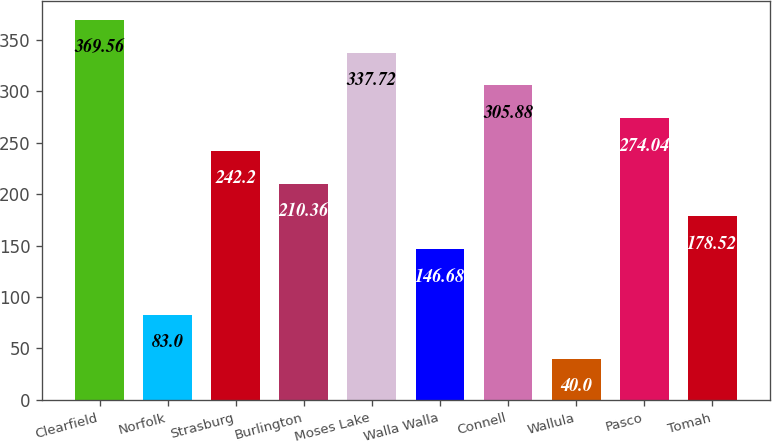Convert chart to OTSL. <chart><loc_0><loc_0><loc_500><loc_500><bar_chart><fcel>Clearfield<fcel>Norfolk<fcel>Strasburg<fcel>Burlington<fcel>Moses Lake<fcel>Walla Walla<fcel>Connell<fcel>Wallula<fcel>Pasco<fcel>Tomah<nl><fcel>369.56<fcel>83<fcel>242.2<fcel>210.36<fcel>337.72<fcel>146.68<fcel>305.88<fcel>40<fcel>274.04<fcel>178.52<nl></chart> 